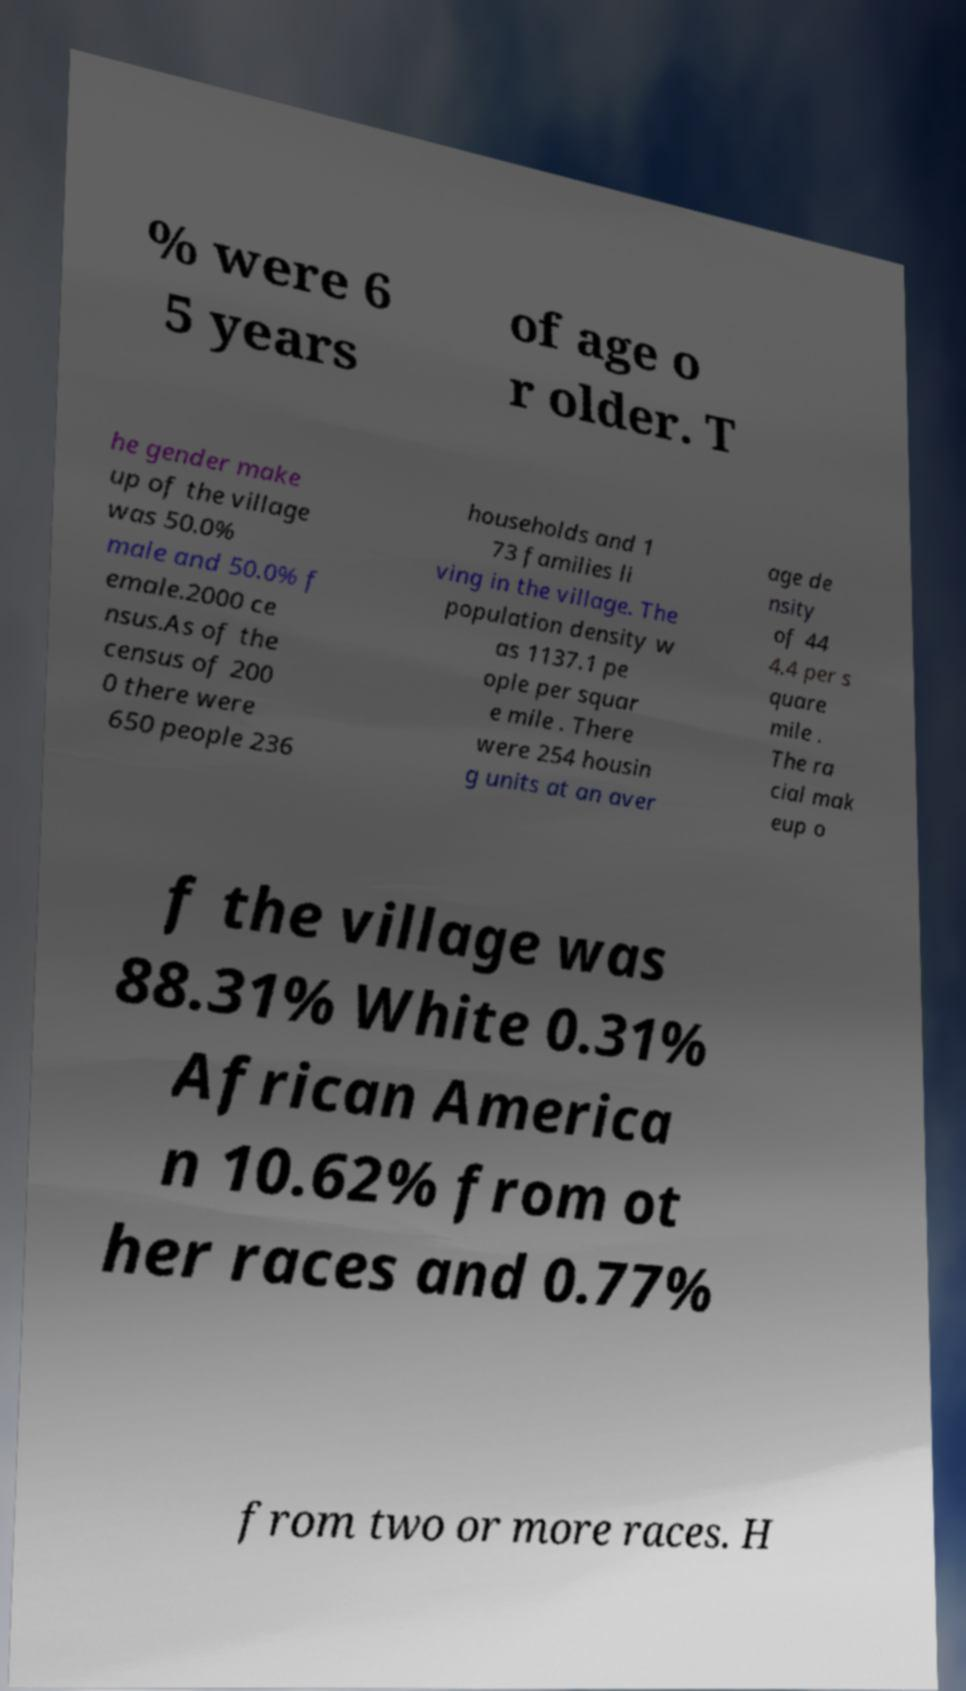What messages or text are displayed in this image? I need them in a readable, typed format. % were 6 5 years of age o r older. T he gender make up of the village was 50.0% male and 50.0% f emale.2000 ce nsus.As of the census of 200 0 there were 650 people 236 households and 1 73 families li ving in the village. The population density w as 1137.1 pe ople per squar e mile . There were 254 housin g units at an aver age de nsity of 44 4.4 per s quare mile . The ra cial mak eup o f the village was 88.31% White 0.31% African America n 10.62% from ot her races and 0.77% from two or more races. H 